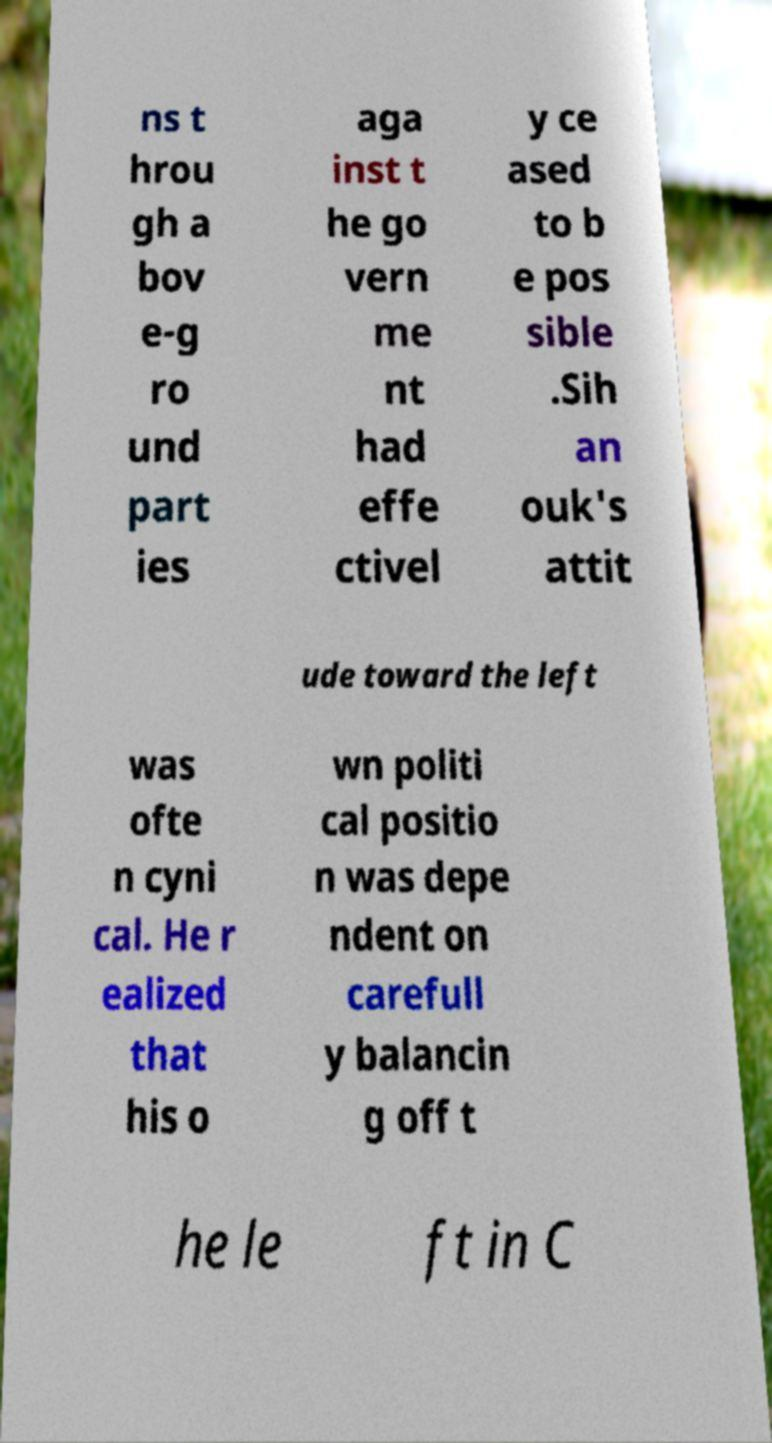Can you accurately transcribe the text from the provided image for me? ns t hrou gh a bov e-g ro und part ies aga inst t he go vern me nt had effe ctivel y ce ased to b e pos sible .Sih an ouk's attit ude toward the left was ofte n cyni cal. He r ealized that his o wn politi cal positio n was depe ndent on carefull y balancin g off t he le ft in C 